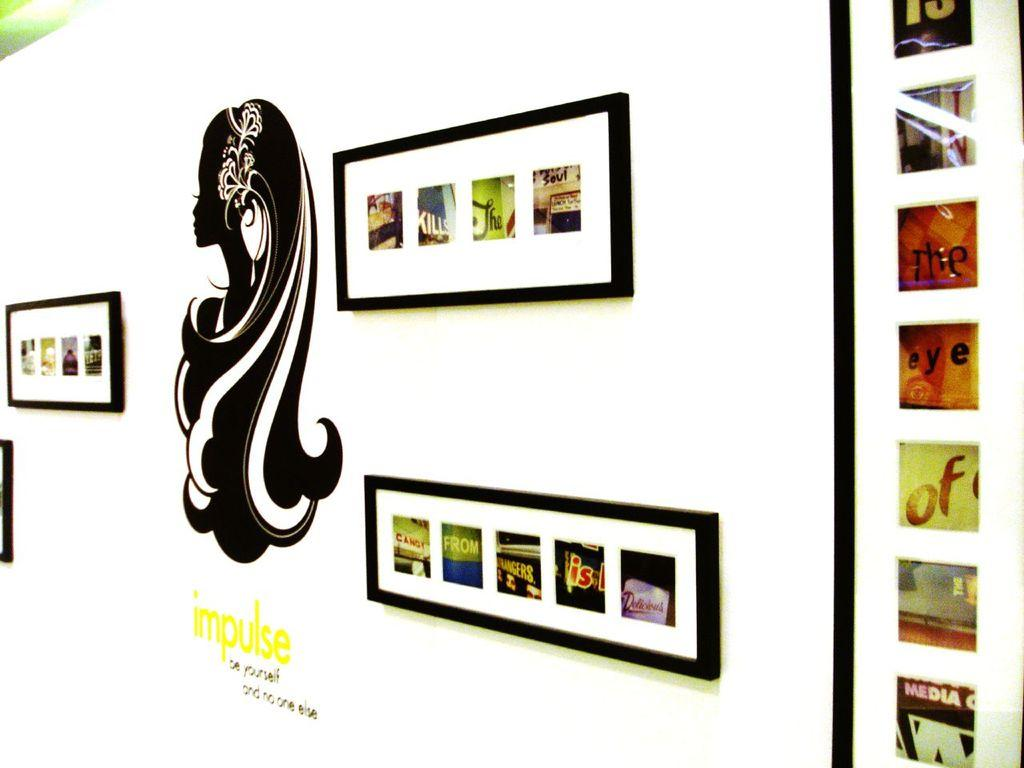Provide a one-sentence caption for the provided image. A woman silhouette is above the words IMPULSE  be yourself and no one else. 